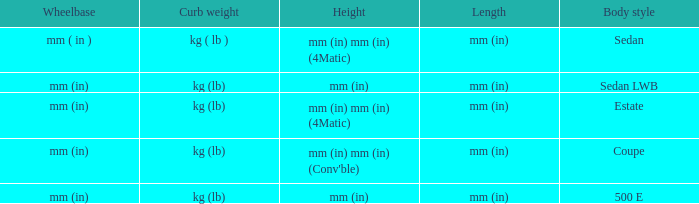What's the curb weight of the model with a wheelbase of mm (in) and height of mm (in) mm (in) (4Matic)? Kg ( lb ), kg (lb). 